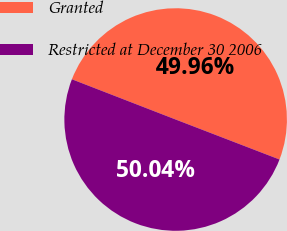Convert chart to OTSL. <chart><loc_0><loc_0><loc_500><loc_500><pie_chart><fcel>Granted<fcel>Restricted at December 30 2006<nl><fcel>49.96%<fcel>50.04%<nl></chart> 